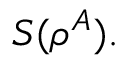Convert formula to latex. <formula><loc_0><loc_0><loc_500><loc_500>\, S ( \rho ^ { A } ) .</formula> 